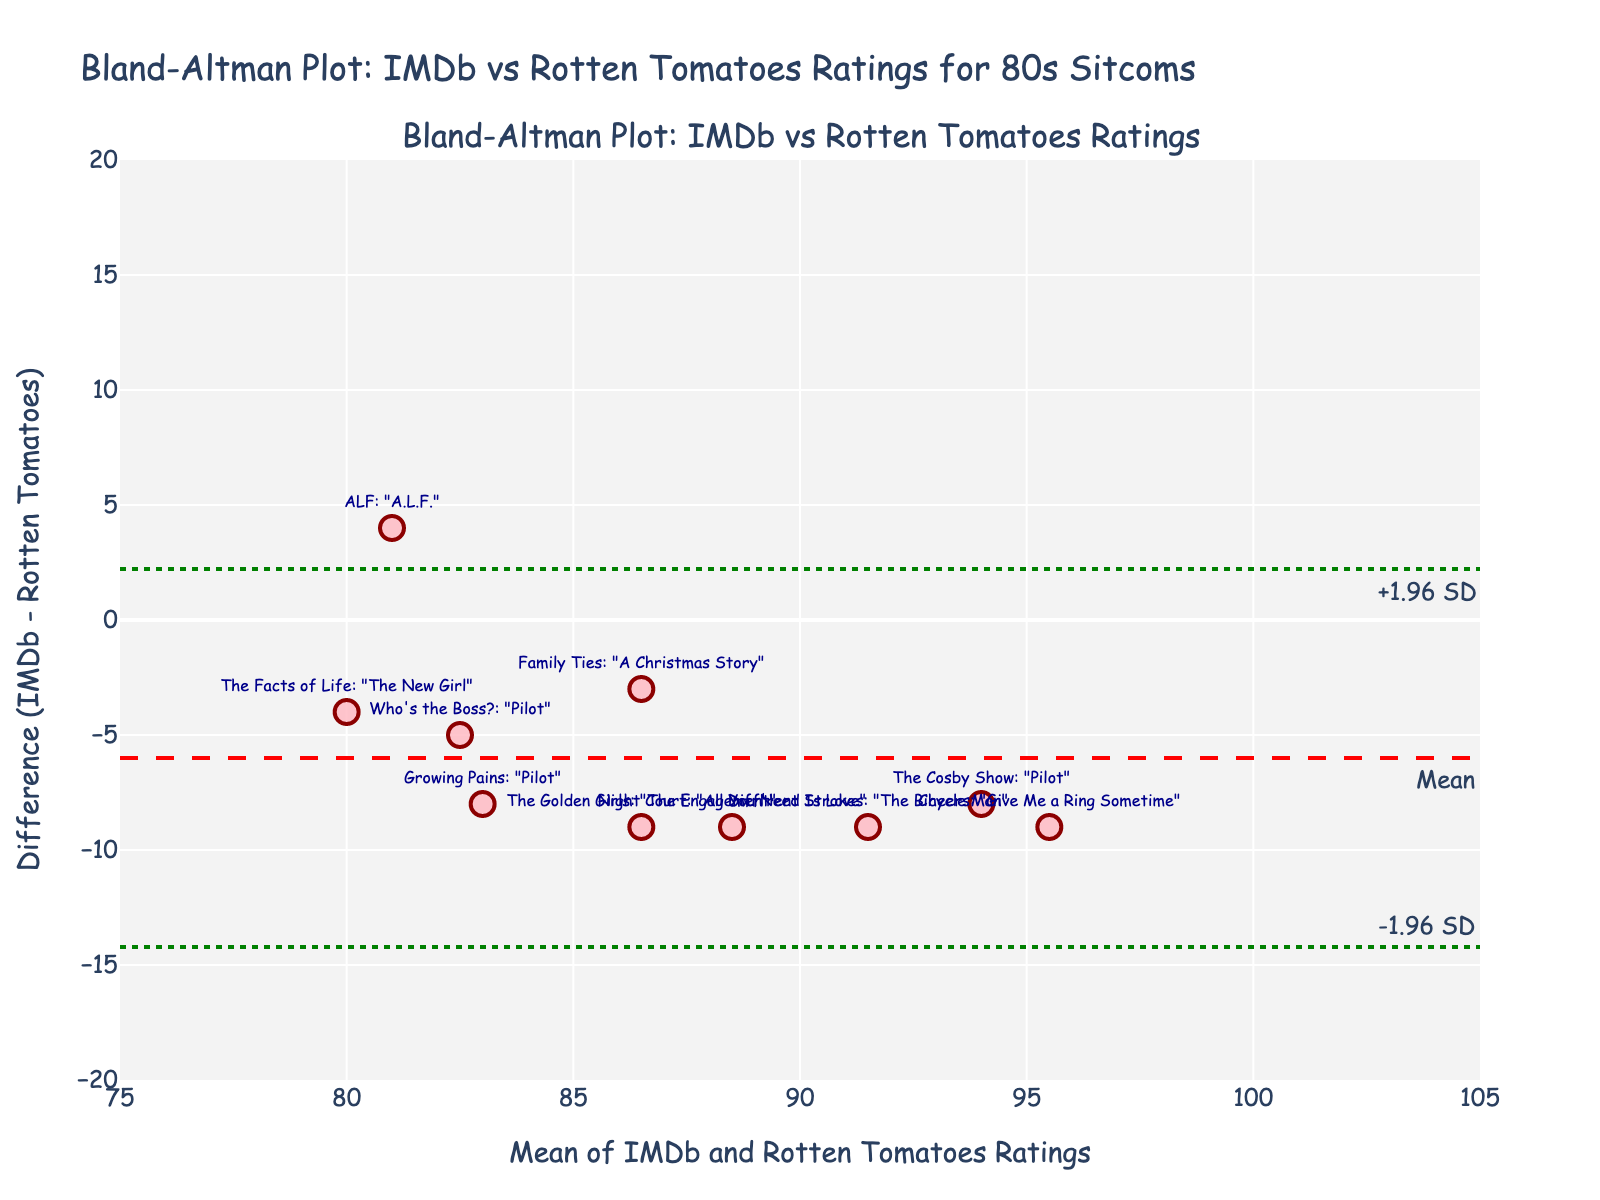What is the title of the plot? The title is clearly written at the top of the figure, stating the overall purpose and scope of the plot. It's crucial to provide quick context for what the plot is about.
Answer: Bland-Altman Plot: IMDb vs Rotten Tomatoes Ratings for 80s Sitcoms What is the y-axis representing? The y-axis label provides a description of what is measured along this axis. In this plot, it shows the difference between IMDb and Rotten Tomatoes ratings.
Answer: Difference (IMDb - Rotten Tomatoes) How many data points are there in the plot? Each data point represents an episode from an 80s sitcom. By counting the markers, we can determine the number of episodes included.
Answer: 10 What is the range of the x-axis? The x-axis range can be determined by observing the minimum and maximum values labeled along the x-axis.
Answer: 75 to 105 Which episode has the highest difference in ratings, and what is this difference? By observing the position of the data points along the y-axis and the accompanying labels, we can identify 'Cheers' as having the highest difference, and we read the y-value at that point.
Answer: Cheers: "Give Me a Ring Sometime", 9.1 What are the lower and upper limits of agreement? The plot includes green dotted lines that mark the lower and upper limits of agreement. These are annotated in the figure. Find these lines and read their y-values.
Answer: -1.96 SD: -14.48, +1.96 SD: 13.06 What is the mean difference between IMDb and Rotten Tomatoes ratings? The mean difference is indicated by the dashed red line that spans horizontally across the plot. Its y-value is marked.
Answer: -0.71 Which episode has the most similar ratings between IMDb and Rotten Tomatoes? The episode with the y-value closest to zero indicates the smallest difference between the two ratings. This can be determined by finding the data point closest to the x-axis (y=0).
Answer: ALF: "A.L.F." What can you infer about the overall agreement between IMDb and Rotten Tomatoes ratings? By looking at the spread of points, the mean difference line, and the limits of agreement, we can infer whether the ratings are generally in agreement or whether there are systematic biases. Many points are within the limits of agreement, suggesting reasonable overall agreement.
Answer: Reasonable overall agreement Do any episodes fall outside the limits of agreement? Observing the points outside the green dotted lines helps identify any episodes that fall outside the limits of agreement, indicating a significant discrepancy.
Answer: None 